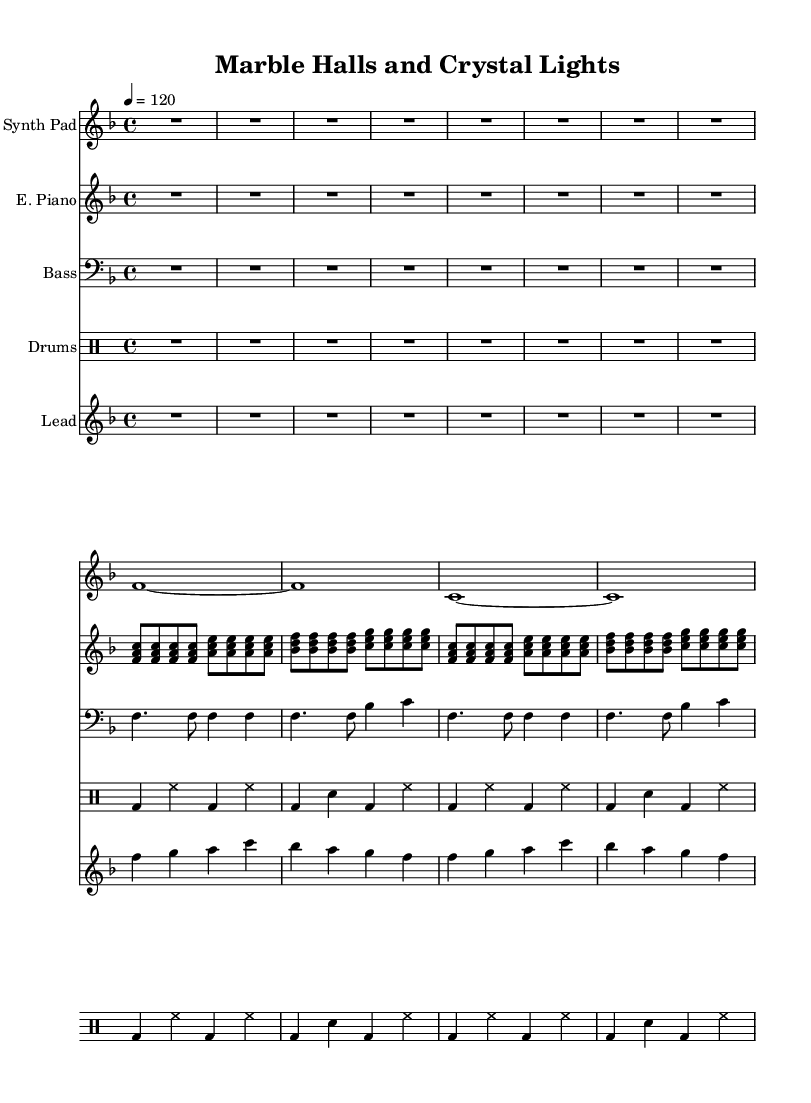What is the key signature of this music? The key signature is F major, which has one flat (B flat). This can be identified in the key signature section at the beginning of the sheet music.
Answer: F major What is the time signature of this music? The time signature is 4/4, which indicates that there are four beats in each measure and a quarter note receives one beat. This is shown clearly at the beginning of the score.
Answer: 4/4 What is the tempo marking of this music? The tempo marking indicates 120 beats per minute, noted as "4 = 120." This provides the performer with information on how fast to play the piece.
Answer: 120 How many measures are present in the lead synth part? Counting the measures in the lead synth part, there are 4 measures highlighted by the vertical bar lines in the staff. Detailed examination shows each section is divided into equal measures.
Answer: 4 Which instrument has the highest pitch range in this score? By analyzing the staves, the lead synth part has the highest pitch range, reaching up to high C, while other parts stay within lower registers. Observing the note placements confirms this.
Answer: Lead Synth How does the bass synth contribute to the overall texture of the composition? The bass synth provides a foundational harmonic support and rhythmic drive, which is characteristic of house music. It utilizes a repetitive pattern that complements the higher elements, creating a fuller sound.
Answer: Harmonic support What element of the drum machine part indicates a lively dance feel? The presence of syncopated bass drums and hi-hat patterns, combined with the regularity of the snare hits, creates a lively rhythm that is typical for dance music. This interplay gives a characteristic groove to the track.
Answer: Syncopated patterns 